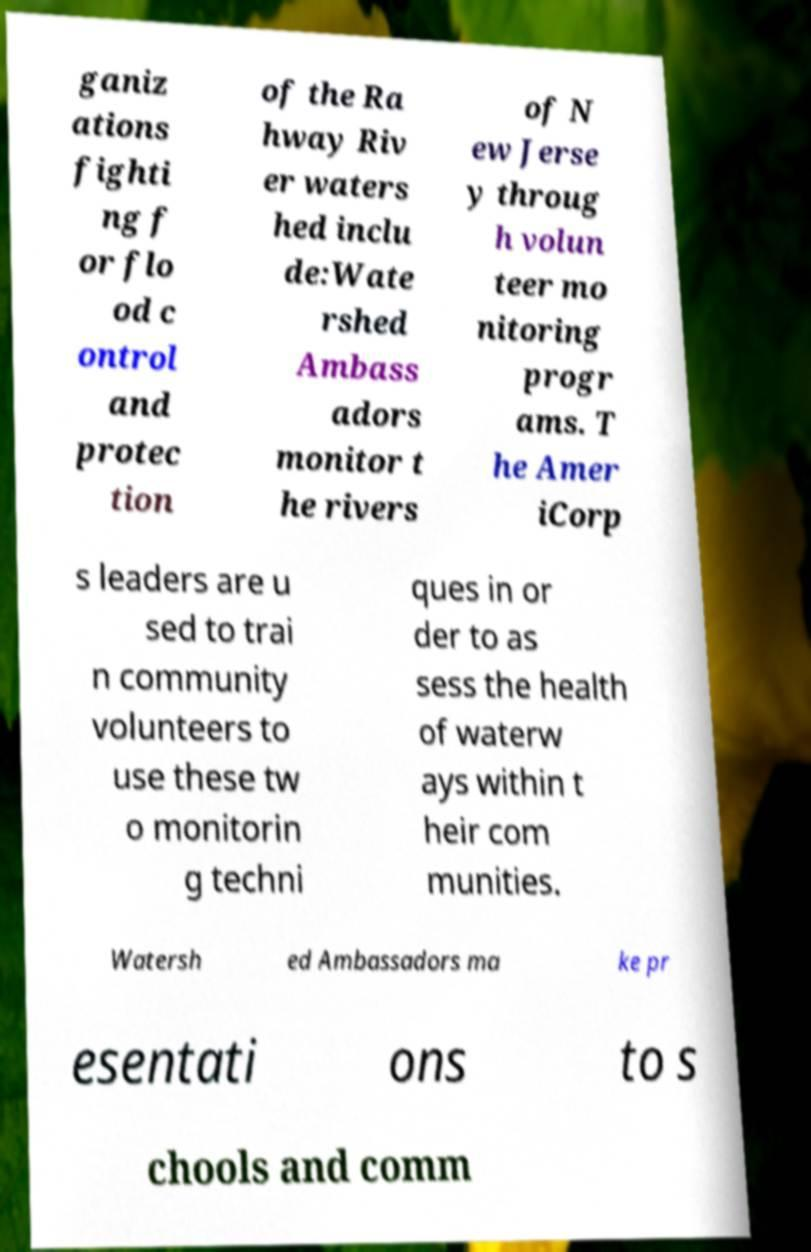Could you extract and type out the text from this image? ganiz ations fighti ng f or flo od c ontrol and protec tion of the Ra hway Riv er waters hed inclu de:Wate rshed Ambass adors monitor t he rivers of N ew Jerse y throug h volun teer mo nitoring progr ams. T he Amer iCorp s leaders are u sed to trai n community volunteers to use these tw o monitorin g techni ques in or der to as sess the health of waterw ays within t heir com munities. Watersh ed Ambassadors ma ke pr esentati ons to s chools and comm 